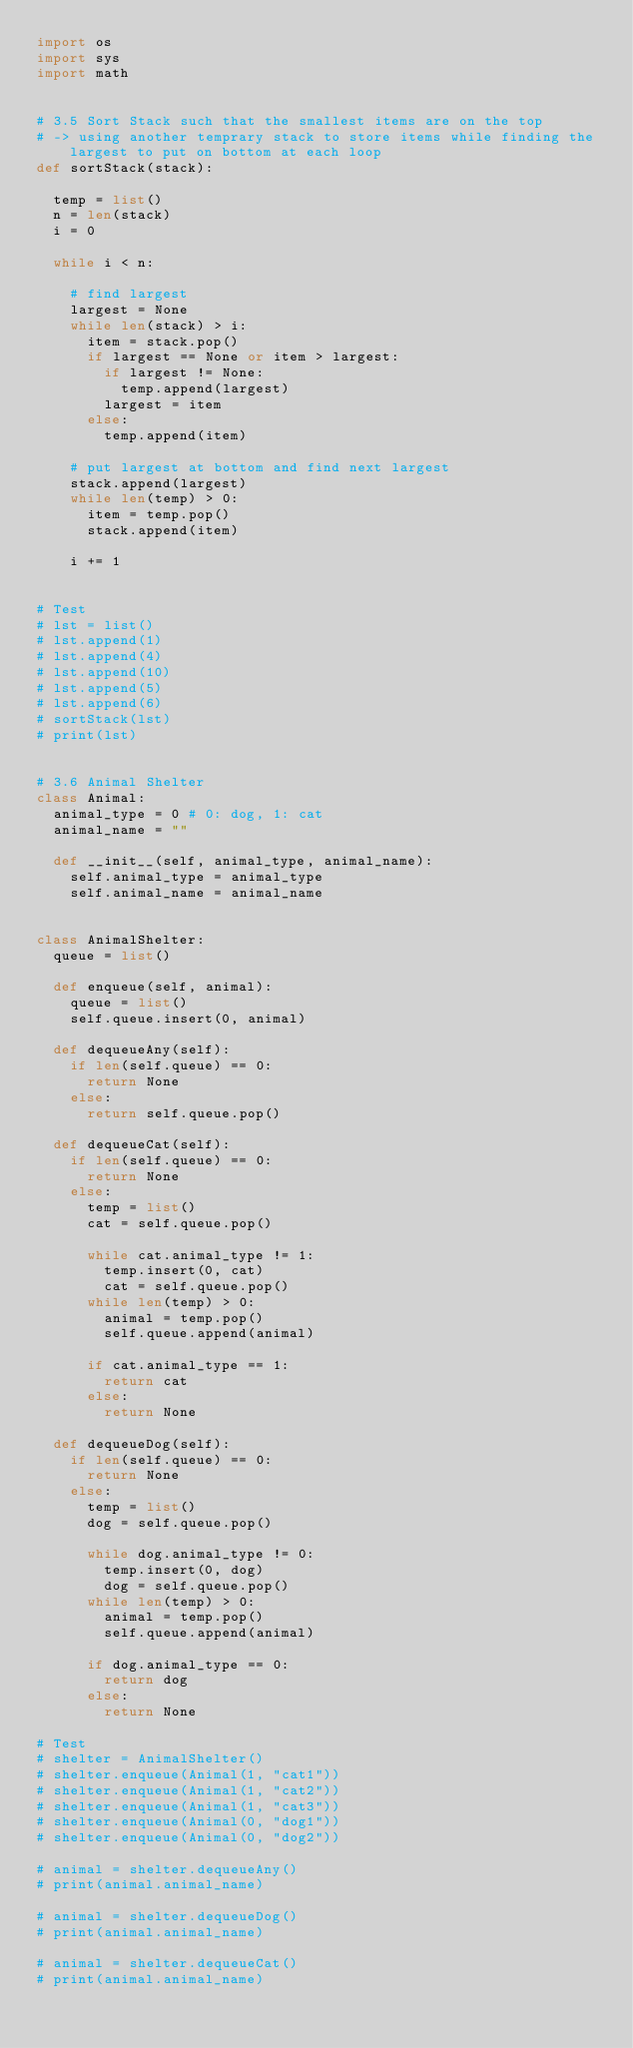Convert code to text. <code><loc_0><loc_0><loc_500><loc_500><_Python_>import os
import sys
import math


# 3.5 Sort Stack such that the smallest items are on the top
# -> using another temprary stack to store items while finding the largest to put on bottom at each loop
def sortStack(stack):
  
  temp = list()
  n = len(stack)
  i = 0

  while i < n:

    # find largest
    largest = None
    while len(stack) > i:
      item = stack.pop()
      if largest == None or item > largest:
        if largest != None:
          temp.append(largest)
        largest = item
      else:
        temp.append(item)
    
    # put largest at bottom and find next largest
    stack.append(largest)
    while len(temp) > 0:
      item = temp.pop()
      stack.append(item)

    i += 1


# Test
# lst = list()
# lst.append(1)
# lst.append(4)
# lst.append(10)
# lst.append(5)
# lst.append(6)
# sortStack(lst)
# print(lst)


# 3.6 Animal Shelter
class Animal:
  animal_type = 0 # 0: dog, 1: cat
  animal_name = ""

  def __init__(self, animal_type, animal_name):
    self.animal_type = animal_type
    self.animal_name = animal_name


class AnimalShelter:
  queue = list()

  def enqueue(self, animal):
    queue = list()
    self.queue.insert(0, animal)

  def dequeueAny(self):
    if len(self.queue) == 0:
      return None
    else:
      return self.queue.pop()

  def dequeueCat(self):
    if len(self.queue) == 0:
      return None
    else:
      temp = list()
      cat = self.queue.pop()

      while cat.animal_type != 1:
        temp.insert(0, cat)
        cat = self.queue.pop()
      while len(temp) > 0:
        animal = temp.pop()
        self.queue.append(animal)

      if cat.animal_type == 1:
        return cat
      else:
        return None

  def dequeueDog(self):
    if len(self.queue) == 0:
      return None
    else:
      temp = list()
      dog = self.queue.pop()

      while dog.animal_type != 0:
        temp.insert(0, dog)
        dog = self.queue.pop()
      while len(temp) > 0:
        animal = temp.pop()
        self.queue.append(animal)

      if dog.animal_type == 0:
        return dog
      else:
        return None

# Test
# shelter = AnimalShelter()
# shelter.enqueue(Animal(1, "cat1"))
# shelter.enqueue(Animal(1, "cat2"))
# shelter.enqueue(Animal(1, "cat3"))
# shelter.enqueue(Animal(0, "dog1"))
# shelter.enqueue(Animal(0, "dog2"))

# animal = shelter.dequeueAny()
# print(animal.animal_name)

# animal = shelter.dequeueDog()
# print(animal.animal_name)

# animal = shelter.dequeueCat()
# print(animal.animal_name)</code> 